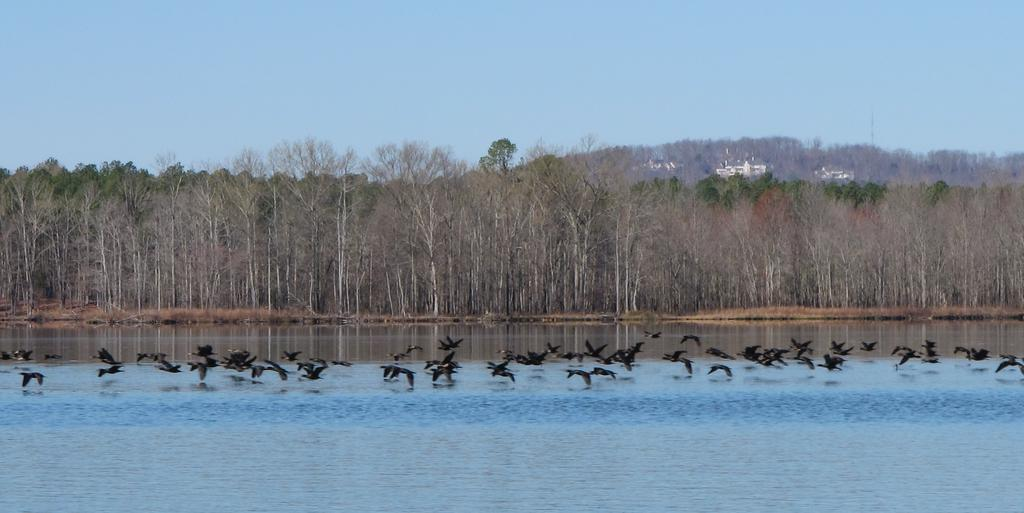What is present at the bottom of the image? There is water at the bottom of the image. What can be seen above the water? There are many black color birds above the water. What type of vegetation is visible in the background of the image? There are tall trees in the background of the image. What is visible at the top of the image? The sky is visible at the top of the image. What type of book is the bird reading in the image? There is no book or reading activity present in the image; it features black color birds above the water. What type of building can be seen in the background of the image? There is no building visible in the image; it features tall trees in the background. 